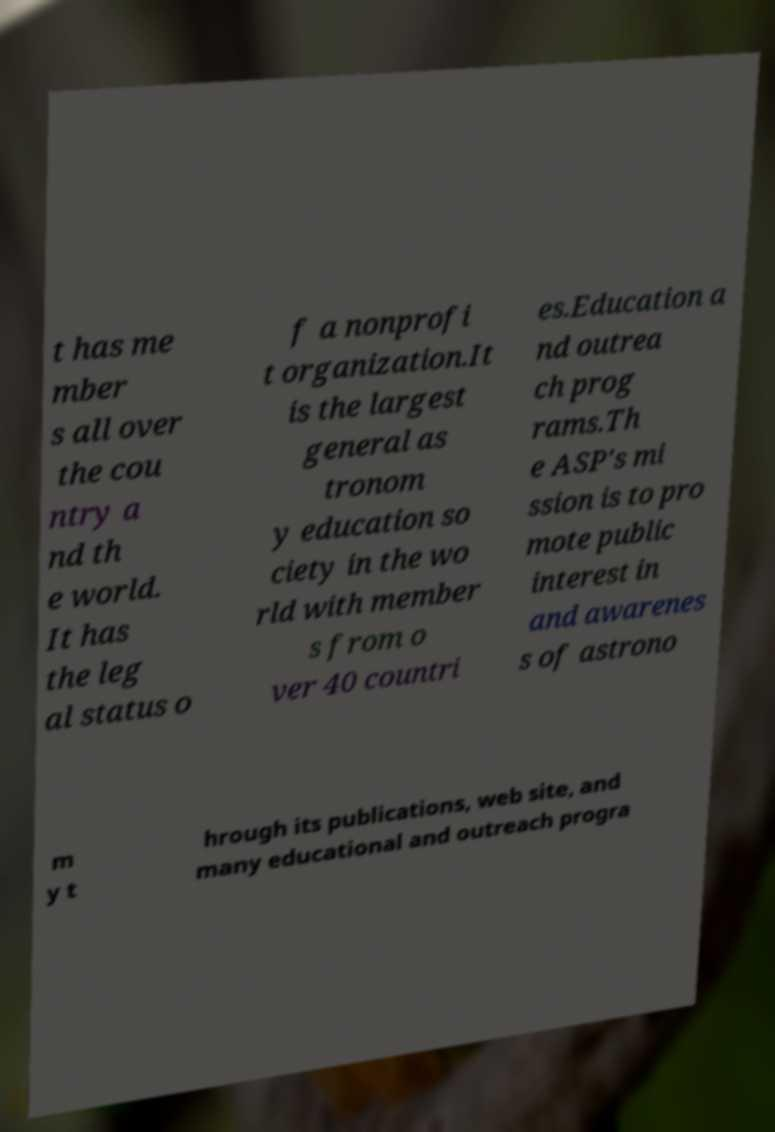What messages or text are displayed in this image? I need them in a readable, typed format. t has me mber s all over the cou ntry a nd th e world. It has the leg al status o f a nonprofi t organization.It is the largest general as tronom y education so ciety in the wo rld with member s from o ver 40 countri es.Education a nd outrea ch prog rams.Th e ASP's mi ssion is to pro mote public interest in and awarenes s of astrono m y t hrough its publications, web site, and many educational and outreach progra 